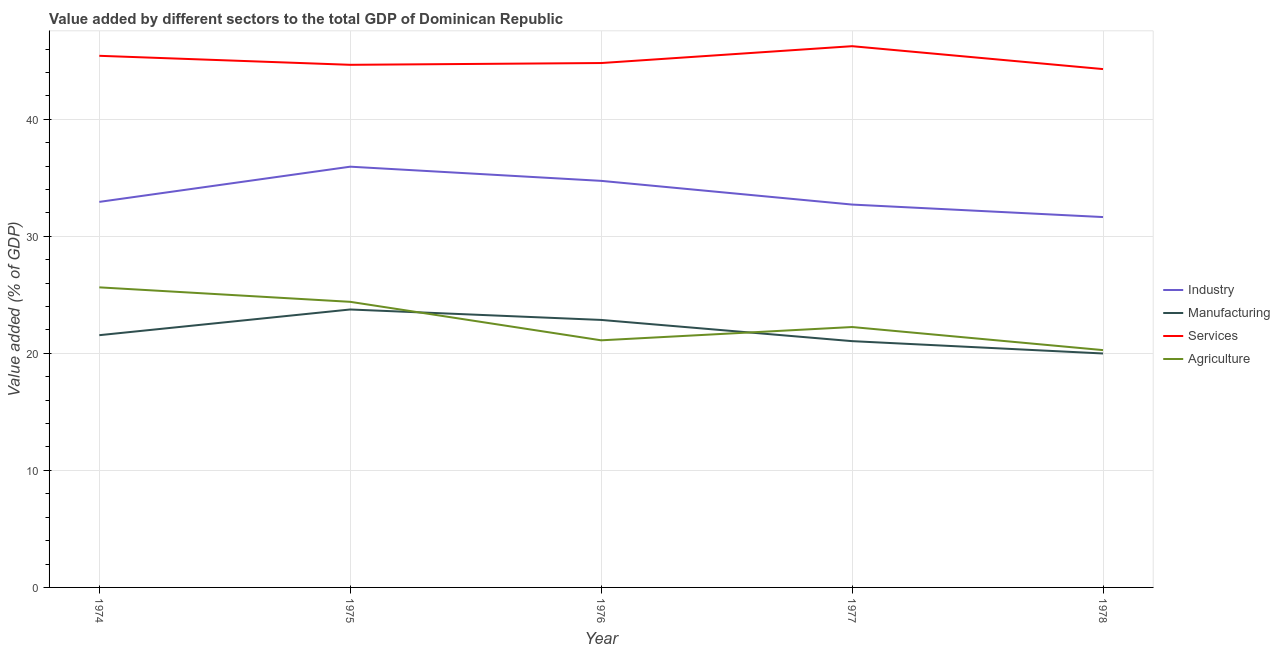Is the number of lines equal to the number of legend labels?
Your answer should be very brief. Yes. What is the value added by agricultural sector in 1976?
Provide a succinct answer. 21.11. Across all years, what is the maximum value added by agricultural sector?
Give a very brief answer. 25.64. Across all years, what is the minimum value added by agricultural sector?
Offer a very short reply. 20.27. In which year was the value added by agricultural sector maximum?
Provide a short and direct response. 1974. In which year was the value added by industrial sector minimum?
Give a very brief answer. 1978. What is the total value added by services sector in the graph?
Your answer should be very brief. 225.4. What is the difference between the value added by services sector in 1974 and that in 1977?
Give a very brief answer. -0.82. What is the difference between the value added by services sector in 1978 and the value added by industrial sector in 1974?
Make the answer very short. 11.35. What is the average value added by manufacturing sector per year?
Offer a very short reply. 21.84. In the year 1974, what is the difference between the value added by agricultural sector and value added by services sector?
Make the answer very short. -19.78. In how many years, is the value added by industrial sector greater than 18 %?
Provide a short and direct response. 5. What is the ratio of the value added by services sector in 1974 to that in 1976?
Ensure brevity in your answer.  1.01. Is the difference between the value added by manufacturing sector in 1974 and 1976 greater than the difference between the value added by industrial sector in 1974 and 1976?
Your response must be concise. Yes. What is the difference between the highest and the second highest value added by services sector?
Your answer should be very brief. 0.82. What is the difference between the highest and the lowest value added by industrial sector?
Your answer should be very brief. 4.3. Is it the case that in every year, the sum of the value added by industrial sector and value added by manufacturing sector is greater than the value added by services sector?
Provide a short and direct response. Yes. Does the value added by manufacturing sector monotonically increase over the years?
Give a very brief answer. No. Is the value added by services sector strictly less than the value added by agricultural sector over the years?
Give a very brief answer. No. What is the difference between two consecutive major ticks on the Y-axis?
Your answer should be compact. 10. Are the values on the major ticks of Y-axis written in scientific E-notation?
Your answer should be compact. No. Does the graph contain grids?
Provide a short and direct response. Yes. How many legend labels are there?
Ensure brevity in your answer.  4. What is the title of the graph?
Provide a short and direct response. Value added by different sectors to the total GDP of Dominican Republic. What is the label or title of the X-axis?
Your response must be concise. Year. What is the label or title of the Y-axis?
Ensure brevity in your answer.  Value added (% of GDP). What is the Value added (% of GDP) of Industry in 1974?
Offer a terse response. 32.94. What is the Value added (% of GDP) in Manufacturing in 1974?
Make the answer very short. 21.55. What is the Value added (% of GDP) of Services in 1974?
Keep it short and to the point. 45.42. What is the Value added (% of GDP) of Agriculture in 1974?
Make the answer very short. 25.64. What is the Value added (% of GDP) of Industry in 1975?
Keep it short and to the point. 35.95. What is the Value added (% of GDP) of Manufacturing in 1975?
Your answer should be compact. 23.75. What is the Value added (% of GDP) in Services in 1975?
Your response must be concise. 44.65. What is the Value added (% of GDP) in Agriculture in 1975?
Make the answer very short. 24.4. What is the Value added (% of GDP) of Industry in 1976?
Keep it short and to the point. 34.73. What is the Value added (% of GDP) of Manufacturing in 1976?
Give a very brief answer. 22.85. What is the Value added (% of GDP) of Services in 1976?
Your answer should be compact. 44.8. What is the Value added (% of GDP) in Agriculture in 1976?
Make the answer very short. 21.11. What is the Value added (% of GDP) in Industry in 1977?
Your response must be concise. 32.71. What is the Value added (% of GDP) of Manufacturing in 1977?
Provide a short and direct response. 21.04. What is the Value added (% of GDP) of Services in 1977?
Offer a terse response. 46.24. What is the Value added (% of GDP) of Agriculture in 1977?
Offer a terse response. 22.25. What is the Value added (% of GDP) in Industry in 1978?
Your response must be concise. 31.64. What is the Value added (% of GDP) in Manufacturing in 1978?
Ensure brevity in your answer.  19.99. What is the Value added (% of GDP) in Services in 1978?
Ensure brevity in your answer.  44.28. What is the Value added (% of GDP) in Agriculture in 1978?
Keep it short and to the point. 20.27. Across all years, what is the maximum Value added (% of GDP) of Industry?
Keep it short and to the point. 35.95. Across all years, what is the maximum Value added (% of GDP) in Manufacturing?
Ensure brevity in your answer.  23.75. Across all years, what is the maximum Value added (% of GDP) of Services?
Make the answer very short. 46.24. Across all years, what is the maximum Value added (% of GDP) of Agriculture?
Your answer should be compact. 25.64. Across all years, what is the minimum Value added (% of GDP) of Industry?
Your answer should be very brief. 31.64. Across all years, what is the minimum Value added (% of GDP) in Manufacturing?
Give a very brief answer. 19.99. Across all years, what is the minimum Value added (% of GDP) in Services?
Your response must be concise. 44.28. Across all years, what is the minimum Value added (% of GDP) of Agriculture?
Your answer should be compact. 20.27. What is the total Value added (% of GDP) of Industry in the graph?
Offer a terse response. 167.97. What is the total Value added (% of GDP) of Manufacturing in the graph?
Your answer should be compact. 109.18. What is the total Value added (% of GDP) in Services in the graph?
Ensure brevity in your answer.  225.4. What is the total Value added (% of GDP) in Agriculture in the graph?
Keep it short and to the point. 113.67. What is the difference between the Value added (% of GDP) in Industry in 1974 and that in 1975?
Offer a very short reply. -3.01. What is the difference between the Value added (% of GDP) of Manufacturing in 1974 and that in 1975?
Provide a succinct answer. -2.2. What is the difference between the Value added (% of GDP) in Services in 1974 and that in 1975?
Ensure brevity in your answer.  0.77. What is the difference between the Value added (% of GDP) in Agriculture in 1974 and that in 1975?
Your answer should be very brief. 1.24. What is the difference between the Value added (% of GDP) of Industry in 1974 and that in 1976?
Provide a short and direct response. -1.8. What is the difference between the Value added (% of GDP) of Manufacturing in 1974 and that in 1976?
Make the answer very short. -1.3. What is the difference between the Value added (% of GDP) of Services in 1974 and that in 1976?
Offer a terse response. 0.62. What is the difference between the Value added (% of GDP) in Agriculture in 1974 and that in 1976?
Offer a very short reply. 4.53. What is the difference between the Value added (% of GDP) of Industry in 1974 and that in 1977?
Keep it short and to the point. 0.23. What is the difference between the Value added (% of GDP) in Manufacturing in 1974 and that in 1977?
Your answer should be compact. 0.51. What is the difference between the Value added (% of GDP) in Services in 1974 and that in 1977?
Offer a terse response. -0.82. What is the difference between the Value added (% of GDP) of Agriculture in 1974 and that in 1977?
Provide a succinct answer. 3.39. What is the difference between the Value added (% of GDP) in Industry in 1974 and that in 1978?
Your answer should be very brief. 1.3. What is the difference between the Value added (% of GDP) of Manufacturing in 1974 and that in 1978?
Make the answer very short. 1.56. What is the difference between the Value added (% of GDP) of Services in 1974 and that in 1978?
Your response must be concise. 1.13. What is the difference between the Value added (% of GDP) of Agriculture in 1974 and that in 1978?
Make the answer very short. 5.36. What is the difference between the Value added (% of GDP) of Industry in 1975 and that in 1976?
Your response must be concise. 1.21. What is the difference between the Value added (% of GDP) in Manufacturing in 1975 and that in 1976?
Provide a succinct answer. 0.89. What is the difference between the Value added (% of GDP) in Services in 1975 and that in 1976?
Keep it short and to the point. -0.15. What is the difference between the Value added (% of GDP) of Agriculture in 1975 and that in 1976?
Give a very brief answer. 3.29. What is the difference between the Value added (% of GDP) in Industry in 1975 and that in 1977?
Give a very brief answer. 3.24. What is the difference between the Value added (% of GDP) of Manufacturing in 1975 and that in 1977?
Provide a succinct answer. 2.71. What is the difference between the Value added (% of GDP) in Services in 1975 and that in 1977?
Offer a very short reply. -1.59. What is the difference between the Value added (% of GDP) of Agriculture in 1975 and that in 1977?
Your response must be concise. 2.15. What is the difference between the Value added (% of GDP) of Industry in 1975 and that in 1978?
Provide a succinct answer. 4.3. What is the difference between the Value added (% of GDP) in Manufacturing in 1975 and that in 1978?
Ensure brevity in your answer.  3.76. What is the difference between the Value added (% of GDP) in Services in 1975 and that in 1978?
Your answer should be very brief. 0.37. What is the difference between the Value added (% of GDP) of Agriculture in 1975 and that in 1978?
Provide a short and direct response. 4.13. What is the difference between the Value added (% of GDP) in Industry in 1976 and that in 1977?
Your response must be concise. 2.02. What is the difference between the Value added (% of GDP) in Manufacturing in 1976 and that in 1977?
Provide a succinct answer. 1.81. What is the difference between the Value added (% of GDP) in Services in 1976 and that in 1977?
Your answer should be compact. -1.44. What is the difference between the Value added (% of GDP) of Agriculture in 1976 and that in 1977?
Provide a succinct answer. -1.14. What is the difference between the Value added (% of GDP) in Industry in 1976 and that in 1978?
Your answer should be very brief. 3.09. What is the difference between the Value added (% of GDP) in Manufacturing in 1976 and that in 1978?
Your answer should be very brief. 2.87. What is the difference between the Value added (% of GDP) in Services in 1976 and that in 1978?
Give a very brief answer. 0.52. What is the difference between the Value added (% of GDP) in Agriculture in 1976 and that in 1978?
Offer a very short reply. 0.84. What is the difference between the Value added (% of GDP) of Industry in 1977 and that in 1978?
Provide a succinct answer. 1.07. What is the difference between the Value added (% of GDP) in Manufacturing in 1977 and that in 1978?
Your answer should be compact. 1.05. What is the difference between the Value added (% of GDP) in Services in 1977 and that in 1978?
Your response must be concise. 1.96. What is the difference between the Value added (% of GDP) in Agriculture in 1977 and that in 1978?
Offer a very short reply. 1.97. What is the difference between the Value added (% of GDP) of Industry in 1974 and the Value added (% of GDP) of Manufacturing in 1975?
Your answer should be compact. 9.19. What is the difference between the Value added (% of GDP) of Industry in 1974 and the Value added (% of GDP) of Services in 1975?
Provide a succinct answer. -11.71. What is the difference between the Value added (% of GDP) in Industry in 1974 and the Value added (% of GDP) in Agriculture in 1975?
Keep it short and to the point. 8.54. What is the difference between the Value added (% of GDP) of Manufacturing in 1974 and the Value added (% of GDP) of Services in 1975?
Your answer should be compact. -23.1. What is the difference between the Value added (% of GDP) in Manufacturing in 1974 and the Value added (% of GDP) in Agriculture in 1975?
Keep it short and to the point. -2.85. What is the difference between the Value added (% of GDP) of Services in 1974 and the Value added (% of GDP) of Agriculture in 1975?
Offer a very short reply. 21.02. What is the difference between the Value added (% of GDP) of Industry in 1974 and the Value added (% of GDP) of Manufacturing in 1976?
Your response must be concise. 10.09. What is the difference between the Value added (% of GDP) of Industry in 1974 and the Value added (% of GDP) of Services in 1976?
Provide a succinct answer. -11.86. What is the difference between the Value added (% of GDP) of Industry in 1974 and the Value added (% of GDP) of Agriculture in 1976?
Make the answer very short. 11.83. What is the difference between the Value added (% of GDP) of Manufacturing in 1974 and the Value added (% of GDP) of Services in 1976?
Make the answer very short. -23.25. What is the difference between the Value added (% of GDP) of Manufacturing in 1974 and the Value added (% of GDP) of Agriculture in 1976?
Give a very brief answer. 0.44. What is the difference between the Value added (% of GDP) in Services in 1974 and the Value added (% of GDP) in Agriculture in 1976?
Ensure brevity in your answer.  24.31. What is the difference between the Value added (% of GDP) of Industry in 1974 and the Value added (% of GDP) of Manufacturing in 1977?
Your answer should be compact. 11.9. What is the difference between the Value added (% of GDP) of Industry in 1974 and the Value added (% of GDP) of Services in 1977?
Make the answer very short. -13.3. What is the difference between the Value added (% of GDP) of Industry in 1974 and the Value added (% of GDP) of Agriculture in 1977?
Ensure brevity in your answer.  10.69. What is the difference between the Value added (% of GDP) in Manufacturing in 1974 and the Value added (% of GDP) in Services in 1977?
Provide a short and direct response. -24.69. What is the difference between the Value added (% of GDP) of Manufacturing in 1974 and the Value added (% of GDP) of Agriculture in 1977?
Ensure brevity in your answer.  -0.7. What is the difference between the Value added (% of GDP) of Services in 1974 and the Value added (% of GDP) of Agriculture in 1977?
Make the answer very short. 23.17. What is the difference between the Value added (% of GDP) in Industry in 1974 and the Value added (% of GDP) in Manufacturing in 1978?
Keep it short and to the point. 12.95. What is the difference between the Value added (% of GDP) in Industry in 1974 and the Value added (% of GDP) in Services in 1978?
Keep it short and to the point. -11.35. What is the difference between the Value added (% of GDP) in Industry in 1974 and the Value added (% of GDP) in Agriculture in 1978?
Ensure brevity in your answer.  12.66. What is the difference between the Value added (% of GDP) of Manufacturing in 1974 and the Value added (% of GDP) of Services in 1978?
Make the answer very short. -22.73. What is the difference between the Value added (% of GDP) of Manufacturing in 1974 and the Value added (% of GDP) of Agriculture in 1978?
Provide a succinct answer. 1.28. What is the difference between the Value added (% of GDP) of Services in 1974 and the Value added (% of GDP) of Agriculture in 1978?
Keep it short and to the point. 25.14. What is the difference between the Value added (% of GDP) in Industry in 1975 and the Value added (% of GDP) in Manufacturing in 1976?
Your response must be concise. 13.09. What is the difference between the Value added (% of GDP) in Industry in 1975 and the Value added (% of GDP) in Services in 1976?
Offer a terse response. -8.85. What is the difference between the Value added (% of GDP) in Industry in 1975 and the Value added (% of GDP) in Agriculture in 1976?
Provide a short and direct response. 14.83. What is the difference between the Value added (% of GDP) of Manufacturing in 1975 and the Value added (% of GDP) of Services in 1976?
Your response must be concise. -21.05. What is the difference between the Value added (% of GDP) in Manufacturing in 1975 and the Value added (% of GDP) in Agriculture in 1976?
Your answer should be compact. 2.63. What is the difference between the Value added (% of GDP) in Services in 1975 and the Value added (% of GDP) in Agriculture in 1976?
Offer a terse response. 23.54. What is the difference between the Value added (% of GDP) in Industry in 1975 and the Value added (% of GDP) in Manufacturing in 1977?
Provide a short and direct response. 14.91. What is the difference between the Value added (% of GDP) in Industry in 1975 and the Value added (% of GDP) in Services in 1977?
Your answer should be compact. -10.29. What is the difference between the Value added (% of GDP) in Industry in 1975 and the Value added (% of GDP) in Agriculture in 1977?
Your answer should be compact. 13.7. What is the difference between the Value added (% of GDP) in Manufacturing in 1975 and the Value added (% of GDP) in Services in 1977?
Provide a succinct answer. -22.49. What is the difference between the Value added (% of GDP) in Manufacturing in 1975 and the Value added (% of GDP) in Agriculture in 1977?
Give a very brief answer. 1.5. What is the difference between the Value added (% of GDP) in Services in 1975 and the Value added (% of GDP) in Agriculture in 1977?
Offer a terse response. 22.4. What is the difference between the Value added (% of GDP) of Industry in 1975 and the Value added (% of GDP) of Manufacturing in 1978?
Ensure brevity in your answer.  15.96. What is the difference between the Value added (% of GDP) of Industry in 1975 and the Value added (% of GDP) of Services in 1978?
Provide a short and direct response. -8.34. What is the difference between the Value added (% of GDP) in Industry in 1975 and the Value added (% of GDP) in Agriculture in 1978?
Keep it short and to the point. 15.67. What is the difference between the Value added (% of GDP) of Manufacturing in 1975 and the Value added (% of GDP) of Services in 1978?
Give a very brief answer. -20.54. What is the difference between the Value added (% of GDP) of Manufacturing in 1975 and the Value added (% of GDP) of Agriculture in 1978?
Ensure brevity in your answer.  3.47. What is the difference between the Value added (% of GDP) in Services in 1975 and the Value added (% of GDP) in Agriculture in 1978?
Give a very brief answer. 24.37. What is the difference between the Value added (% of GDP) in Industry in 1976 and the Value added (% of GDP) in Manufacturing in 1977?
Your answer should be compact. 13.69. What is the difference between the Value added (% of GDP) of Industry in 1976 and the Value added (% of GDP) of Services in 1977?
Your response must be concise. -11.51. What is the difference between the Value added (% of GDP) of Industry in 1976 and the Value added (% of GDP) of Agriculture in 1977?
Keep it short and to the point. 12.49. What is the difference between the Value added (% of GDP) in Manufacturing in 1976 and the Value added (% of GDP) in Services in 1977?
Offer a terse response. -23.39. What is the difference between the Value added (% of GDP) in Manufacturing in 1976 and the Value added (% of GDP) in Agriculture in 1977?
Your answer should be very brief. 0.61. What is the difference between the Value added (% of GDP) of Services in 1976 and the Value added (% of GDP) of Agriculture in 1977?
Offer a terse response. 22.55. What is the difference between the Value added (% of GDP) in Industry in 1976 and the Value added (% of GDP) in Manufacturing in 1978?
Your answer should be compact. 14.75. What is the difference between the Value added (% of GDP) of Industry in 1976 and the Value added (% of GDP) of Services in 1978?
Offer a very short reply. -9.55. What is the difference between the Value added (% of GDP) in Industry in 1976 and the Value added (% of GDP) in Agriculture in 1978?
Your answer should be compact. 14.46. What is the difference between the Value added (% of GDP) in Manufacturing in 1976 and the Value added (% of GDP) in Services in 1978?
Keep it short and to the point. -21.43. What is the difference between the Value added (% of GDP) of Manufacturing in 1976 and the Value added (% of GDP) of Agriculture in 1978?
Give a very brief answer. 2.58. What is the difference between the Value added (% of GDP) of Services in 1976 and the Value added (% of GDP) of Agriculture in 1978?
Offer a very short reply. 24.53. What is the difference between the Value added (% of GDP) of Industry in 1977 and the Value added (% of GDP) of Manufacturing in 1978?
Your response must be concise. 12.72. What is the difference between the Value added (% of GDP) in Industry in 1977 and the Value added (% of GDP) in Services in 1978?
Give a very brief answer. -11.57. What is the difference between the Value added (% of GDP) of Industry in 1977 and the Value added (% of GDP) of Agriculture in 1978?
Offer a very short reply. 12.43. What is the difference between the Value added (% of GDP) of Manufacturing in 1977 and the Value added (% of GDP) of Services in 1978?
Ensure brevity in your answer.  -23.24. What is the difference between the Value added (% of GDP) of Manufacturing in 1977 and the Value added (% of GDP) of Agriculture in 1978?
Ensure brevity in your answer.  0.77. What is the difference between the Value added (% of GDP) in Services in 1977 and the Value added (% of GDP) in Agriculture in 1978?
Your answer should be very brief. 25.97. What is the average Value added (% of GDP) in Industry per year?
Your answer should be compact. 33.59. What is the average Value added (% of GDP) in Manufacturing per year?
Your answer should be compact. 21.84. What is the average Value added (% of GDP) of Services per year?
Provide a short and direct response. 45.08. What is the average Value added (% of GDP) in Agriculture per year?
Offer a very short reply. 22.73. In the year 1974, what is the difference between the Value added (% of GDP) of Industry and Value added (% of GDP) of Manufacturing?
Keep it short and to the point. 11.39. In the year 1974, what is the difference between the Value added (% of GDP) of Industry and Value added (% of GDP) of Services?
Your answer should be compact. -12.48. In the year 1974, what is the difference between the Value added (% of GDP) in Industry and Value added (% of GDP) in Agriculture?
Your answer should be very brief. 7.3. In the year 1974, what is the difference between the Value added (% of GDP) in Manufacturing and Value added (% of GDP) in Services?
Offer a terse response. -23.87. In the year 1974, what is the difference between the Value added (% of GDP) in Manufacturing and Value added (% of GDP) in Agriculture?
Keep it short and to the point. -4.09. In the year 1974, what is the difference between the Value added (% of GDP) of Services and Value added (% of GDP) of Agriculture?
Give a very brief answer. 19.78. In the year 1975, what is the difference between the Value added (% of GDP) in Industry and Value added (% of GDP) in Manufacturing?
Offer a terse response. 12.2. In the year 1975, what is the difference between the Value added (% of GDP) in Industry and Value added (% of GDP) in Services?
Provide a succinct answer. -8.7. In the year 1975, what is the difference between the Value added (% of GDP) in Industry and Value added (% of GDP) in Agriculture?
Provide a short and direct response. 11.55. In the year 1975, what is the difference between the Value added (% of GDP) of Manufacturing and Value added (% of GDP) of Services?
Provide a succinct answer. -20.9. In the year 1975, what is the difference between the Value added (% of GDP) of Manufacturing and Value added (% of GDP) of Agriculture?
Provide a short and direct response. -0.65. In the year 1975, what is the difference between the Value added (% of GDP) in Services and Value added (% of GDP) in Agriculture?
Offer a very short reply. 20.25. In the year 1976, what is the difference between the Value added (% of GDP) of Industry and Value added (% of GDP) of Manufacturing?
Provide a short and direct response. 11.88. In the year 1976, what is the difference between the Value added (% of GDP) of Industry and Value added (% of GDP) of Services?
Make the answer very short. -10.07. In the year 1976, what is the difference between the Value added (% of GDP) in Industry and Value added (% of GDP) in Agriculture?
Offer a terse response. 13.62. In the year 1976, what is the difference between the Value added (% of GDP) of Manufacturing and Value added (% of GDP) of Services?
Make the answer very short. -21.95. In the year 1976, what is the difference between the Value added (% of GDP) in Manufacturing and Value added (% of GDP) in Agriculture?
Provide a short and direct response. 1.74. In the year 1976, what is the difference between the Value added (% of GDP) of Services and Value added (% of GDP) of Agriculture?
Make the answer very short. 23.69. In the year 1977, what is the difference between the Value added (% of GDP) in Industry and Value added (% of GDP) in Manufacturing?
Ensure brevity in your answer.  11.67. In the year 1977, what is the difference between the Value added (% of GDP) in Industry and Value added (% of GDP) in Services?
Provide a short and direct response. -13.53. In the year 1977, what is the difference between the Value added (% of GDP) of Industry and Value added (% of GDP) of Agriculture?
Provide a short and direct response. 10.46. In the year 1977, what is the difference between the Value added (% of GDP) of Manufacturing and Value added (% of GDP) of Services?
Make the answer very short. -25.2. In the year 1977, what is the difference between the Value added (% of GDP) in Manufacturing and Value added (% of GDP) in Agriculture?
Make the answer very short. -1.21. In the year 1977, what is the difference between the Value added (% of GDP) of Services and Value added (% of GDP) of Agriculture?
Make the answer very short. 23.99. In the year 1978, what is the difference between the Value added (% of GDP) in Industry and Value added (% of GDP) in Manufacturing?
Ensure brevity in your answer.  11.66. In the year 1978, what is the difference between the Value added (% of GDP) in Industry and Value added (% of GDP) in Services?
Your answer should be compact. -12.64. In the year 1978, what is the difference between the Value added (% of GDP) in Industry and Value added (% of GDP) in Agriculture?
Give a very brief answer. 11.37. In the year 1978, what is the difference between the Value added (% of GDP) in Manufacturing and Value added (% of GDP) in Services?
Keep it short and to the point. -24.3. In the year 1978, what is the difference between the Value added (% of GDP) in Manufacturing and Value added (% of GDP) in Agriculture?
Keep it short and to the point. -0.29. In the year 1978, what is the difference between the Value added (% of GDP) in Services and Value added (% of GDP) in Agriculture?
Make the answer very short. 24.01. What is the ratio of the Value added (% of GDP) of Industry in 1974 to that in 1975?
Provide a succinct answer. 0.92. What is the ratio of the Value added (% of GDP) in Manufacturing in 1974 to that in 1975?
Offer a terse response. 0.91. What is the ratio of the Value added (% of GDP) in Services in 1974 to that in 1975?
Keep it short and to the point. 1.02. What is the ratio of the Value added (% of GDP) of Agriculture in 1974 to that in 1975?
Provide a succinct answer. 1.05. What is the ratio of the Value added (% of GDP) in Industry in 1974 to that in 1976?
Give a very brief answer. 0.95. What is the ratio of the Value added (% of GDP) of Manufacturing in 1974 to that in 1976?
Your response must be concise. 0.94. What is the ratio of the Value added (% of GDP) of Services in 1974 to that in 1976?
Make the answer very short. 1.01. What is the ratio of the Value added (% of GDP) in Agriculture in 1974 to that in 1976?
Offer a terse response. 1.21. What is the ratio of the Value added (% of GDP) in Manufacturing in 1974 to that in 1977?
Offer a very short reply. 1.02. What is the ratio of the Value added (% of GDP) of Services in 1974 to that in 1977?
Offer a very short reply. 0.98. What is the ratio of the Value added (% of GDP) of Agriculture in 1974 to that in 1977?
Your response must be concise. 1.15. What is the ratio of the Value added (% of GDP) of Industry in 1974 to that in 1978?
Offer a very short reply. 1.04. What is the ratio of the Value added (% of GDP) of Manufacturing in 1974 to that in 1978?
Provide a succinct answer. 1.08. What is the ratio of the Value added (% of GDP) of Services in 1974 to that in 1978?
Provide a short and direct response. 1.03. What is the ratio of the Value added (% of GDP) in Agriculture in 1974 to that in 1978?
Offer a very short reply. 1.26. What is the ratio of the Value added (% of GDP) in Industry in 1975 to that in 1976?
Provide a short and direct response. 1.03. What is the ratio of the Value added (% of GDP) in Manufacturing in 1975 to that in 1976?
Give a very brief answer. 1.04. What is the ratio of the Value added (% of GDP) of Agriculture in 1975 to that in 1976?
Provide a short and direct response. 1.16. What is the ratio of the Value added (% of GDP) in Industry in 1975 to that in 1977?
Provide a short and direct response. 1.1. What is the ratio of the Value added (% of GDP) in Manufacturing in 1975 to that in 1977?
Your answer should be compact. 1.13. What is the ratio of the Value added (% of GDP) of Services in 1975 to that in 1977?
Your answer should be very brief. 0.97. What is the ratio of the Value added (% of GDP) in Agriculture in 1975 to that in 1977?
Ensure brevity in your answer.  1.1. What is the ratio of the Value added (% of GDP) in Industry in 1975 to that in 1978?
Keep it short and to the point. 1.14. What is the ratio of the Value added (% of GDP) of Manufacturing in 1975 to that in 1978?
Give a very brief answer. 1.19. What is the ratio of the Value added (% of GDP) in Services in 1975 to that in 1978?
Offer a terse response. 1.01. What is the ratio of the Value added (% of GDP) in Agriculture in 1975 to that in 1978?
Offer a very short reply. 1.2. What is the ratio of the Value added (% of GDP) of Industry in 1976 to that in 1977?
Give a very brief answer. 1.06. What is the ratio of the Value added (% of GDP) of Manufacturing in 1976 to that in 1977?
Provide a succinct answer. 1.09. What is the ratio of the Value added (% of GDP) of Services in 1976 to that in 1977?
Give a very brief answer. 0.97. What is the ratio of the Value added (% of GDP) of Agriculture in 1976 to that in 1977?
Give a very brief answer. 0.95. What is the ratio of the Value added (% of GDP) of Industry in 1976 to that in 1978?
Give a very brief answer. 1.1. What is the ratio of the Value added (% of GDP) of Manufacturing in 1976 to that in 1978?
Provide a succinct answer. 1.14. What is the ratio of the Value added (% of GDP) in Services in 1976 to that in 1978?
Your answer should be compact. 1.01. What is the ratio of the Value added (% of GDP) in Agriculture in 1976 to that in 1978?
Provide a succinct answer. 1.04. What is the ratio of the Value added (% of GDP) in Industry in 1977 to that in 1978?
Offer a terse response. 1.03. What is the ratio of the Value added (% of GDP) in Manufacturing in 1977 to that in 1978?
Make the answer very short. 1.05. What is the ratio of the Value added (% of GDP) of Services in 1977 to that in 1978?
Your answer should be compact. 1.04. What is the ratio of the Value added (% of GDP) of Agriculture in 1977 to that in 1978?
Offer a terse response. 1.1. What is the difference between the highest and the second highest Value added (% of GDP) of Industry?
Keep it short and to the point. 1.21. What is the difference between the highest and the second highest Value added (% of GDP) of Manufacturing?
Keep it short and to the point. 0.89. What is the difference between the highest and the second highest Value added (% of GDP) of Services?
Ensure brevity in your answer.  0.82. What is the difference between the highest and the second highest Value added (% of GDP) of Agriculture?
Keep it short and to the point. 1.24. What is the difference between the highest and the lowest Value added (% of GDP) of Industry?
Give a very brief answer. 4.3. What is the difference between the highest and the lowest Value added (% of GDP) in Manufacturing?
Make the answer very short. 3.76. What is the difference between the highest and the lowest Value added (% of GDP) in Services?
Provide a succinct answer. 1.96. What is the difference between the highest and the lowest Value added (% of GDP) in Agriculture?
Your response must be concise. 5.36. 